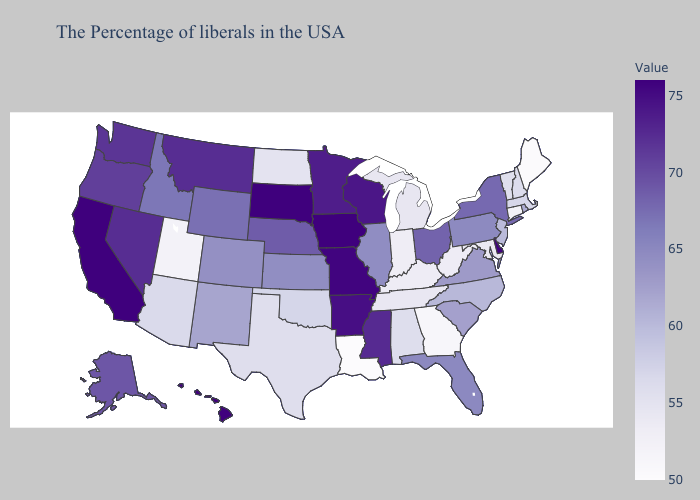Does Nebraska have a higher value than Hawaii?
Keep it brief. No. Which states have the lowest value in the Northeast?
Give a very brief answer. Maine. Does Alaska have the highest value in the West?
Keep it brief. No. Which states have the lowest value in the Northeast?
Short answer required. Maine. Does the map have missing data?
Quick response, please. No. Which states have the highest value in the USA?
Answer briefly. Iowa, South Dakota, California. Is the legend a continuous bar?
Give a very brief answer. Yes. 